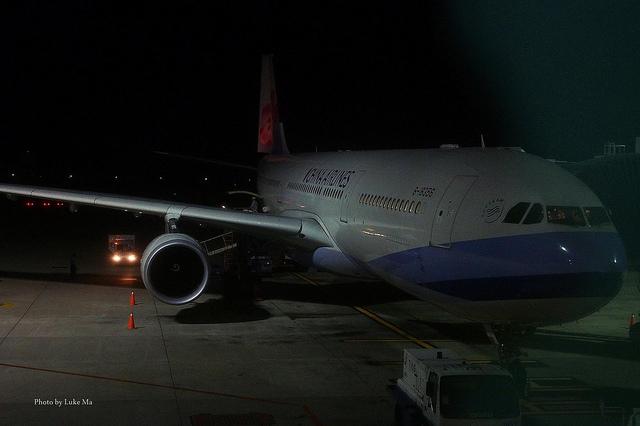Why are there cones on side of the plane?
Give a very brief answer. Caution. Is this a professional picture of an airplane?
Quick response, please. No. How many lights does the plane have?
Keep it brief. 0. Are the lights on or off?
Short answer required. Off. Any people in the picture?
Be succinct. No. What is the name of the airplane?
Give a very brief answer. Delta airlines. Is this a museum or an active hangar?
Be succinct. Active. Is this a passenger airplane?
Concise answer only. Yes. How many cones are in the picture?
Short answer required. 2. Is the sun setting?
Short answer required. No. 